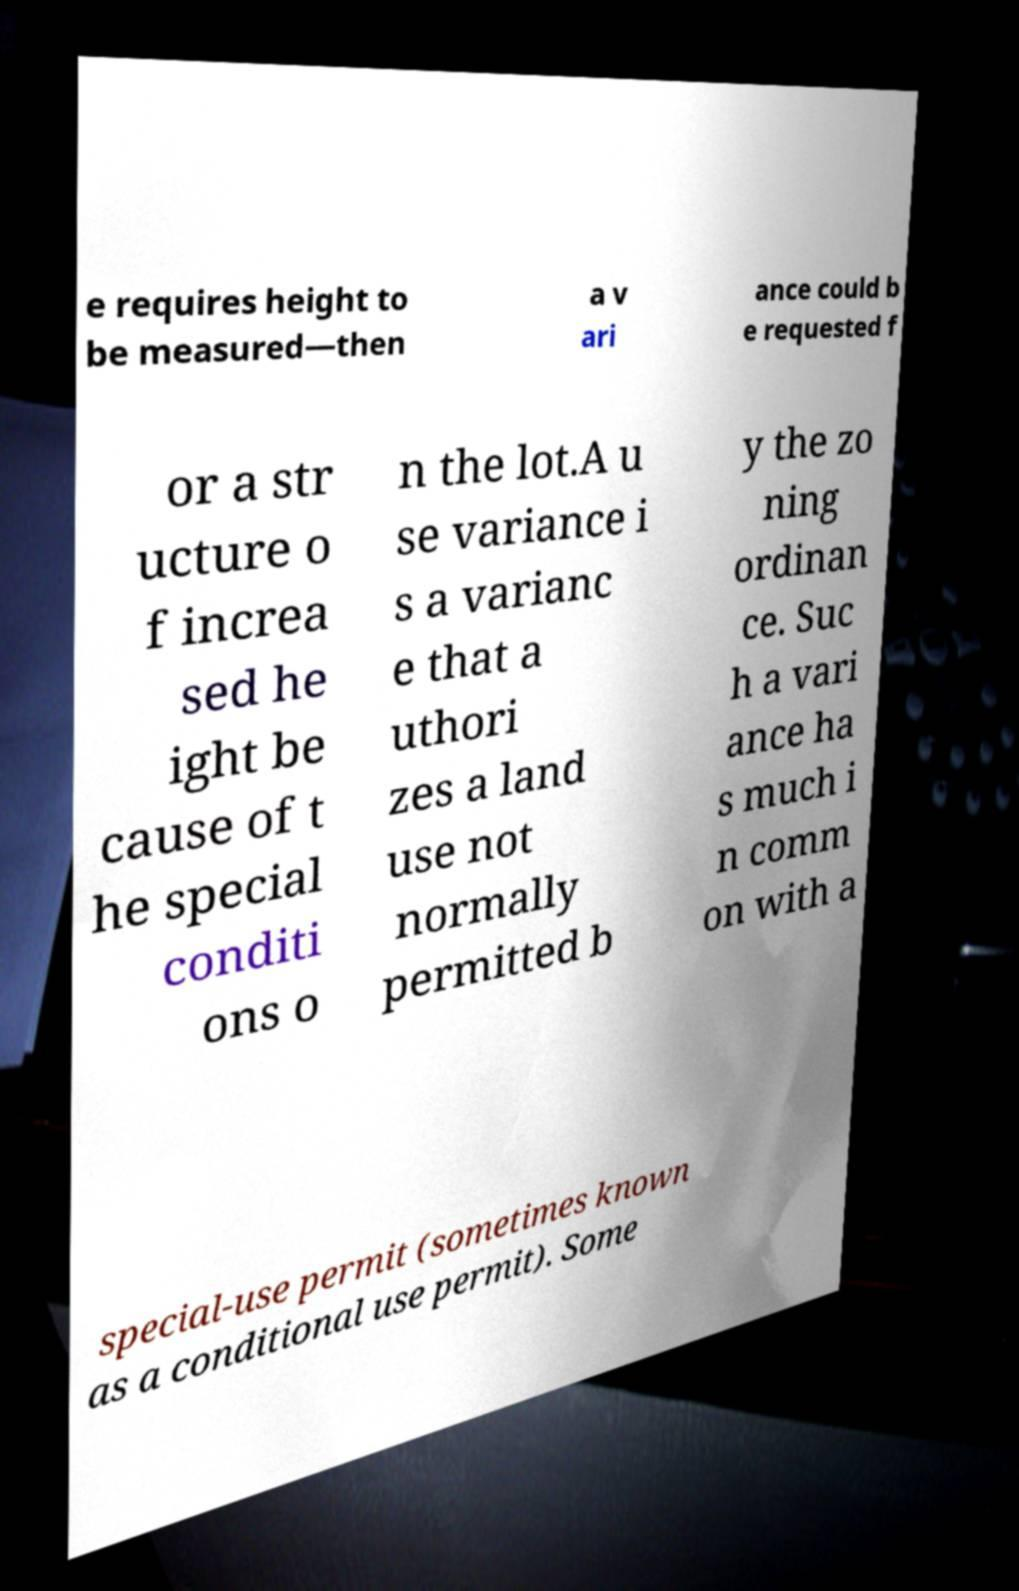Can you accurately transcribe the text from the provided image for me? e requires height to be measured—then a v ari ance could b e requested f or a str ucture o f increa sed he ight be cause of t he special conditi ons o n the lot.A u se variance i s a varianc e that a uthori zes a land use not normally permitted b y the zo ning ordinan ce. Suc h a vari ance ha s much i n comm on with a special-use permit (sometimes known as a conditional use permit). Some 